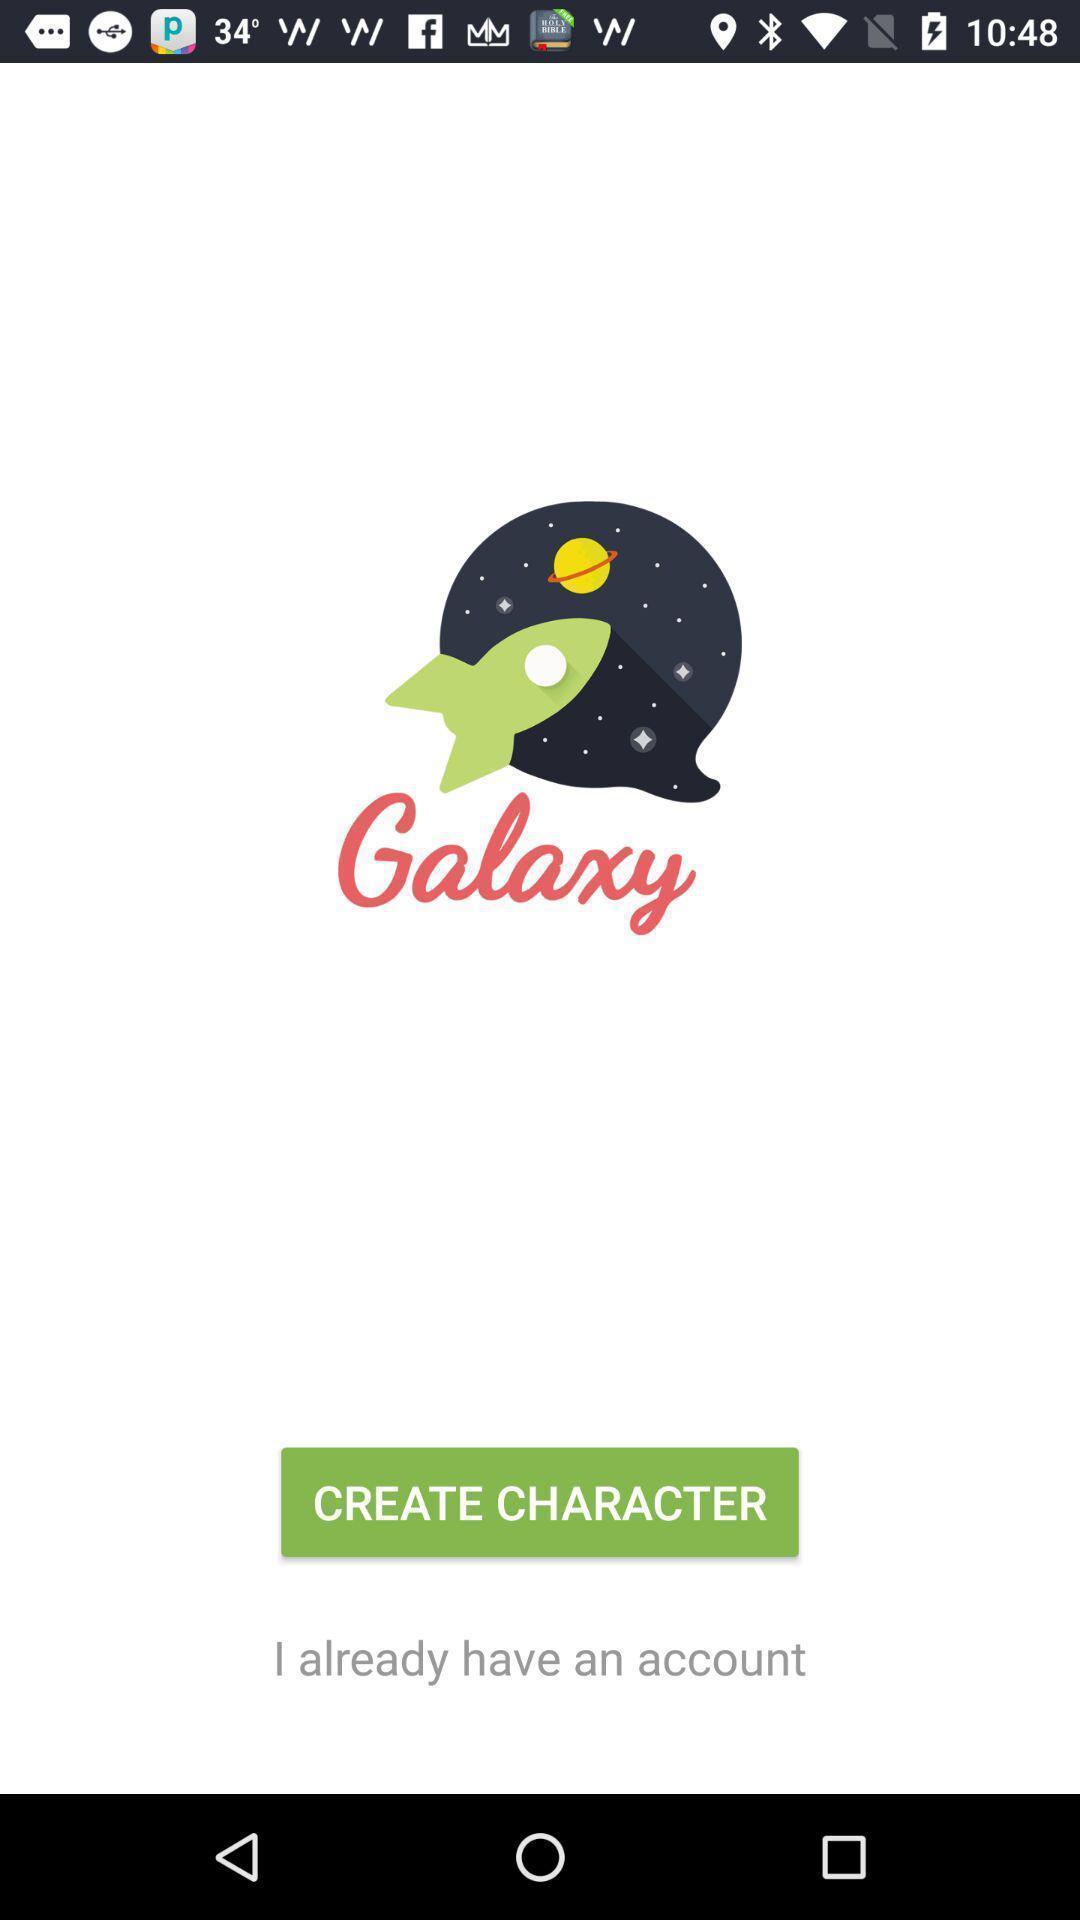Summarize the information in this screenshot. Welcome page. 